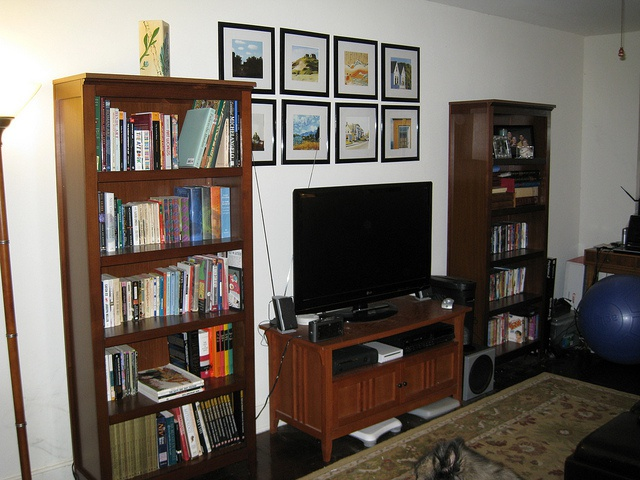Describe the objects in this image and their specific colors. I can see book in beige, black, gray, olive, and darkgray tones, tv in beige, black, olive, and darkgreen tones, book in beige, gray, black, darkgray, and lightgray tones, chair in black and beige tones, and cat in beige, black, and gray tones in this image. 